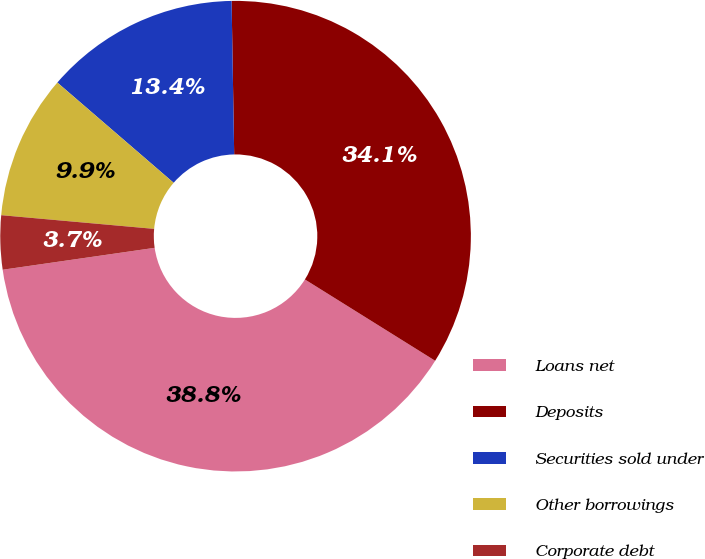<chart> <loc_0><loc_0><loc_500><loc_500><pie_chart><fcel>Loans net<fcel>Deposits<fcel>Securities sold under<fcel>Other borrowings<fcel>Corporate debt<nl><fcel>38.84%<fcel>34.15%<fcel>13.41%<fcel>9.9%<fcel>3.7%<nl></chart> 